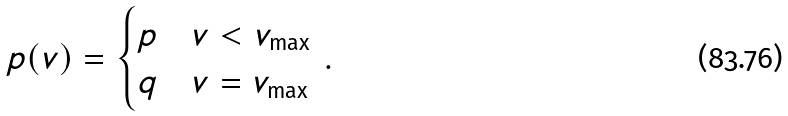<formula> <loc_0><loc_0><loc_500><loc_500>p ( v ) = \begin{cases} p & v < v _ { \max } \\ q & v = v _ { \max } \end{cases} \, .</formula> 